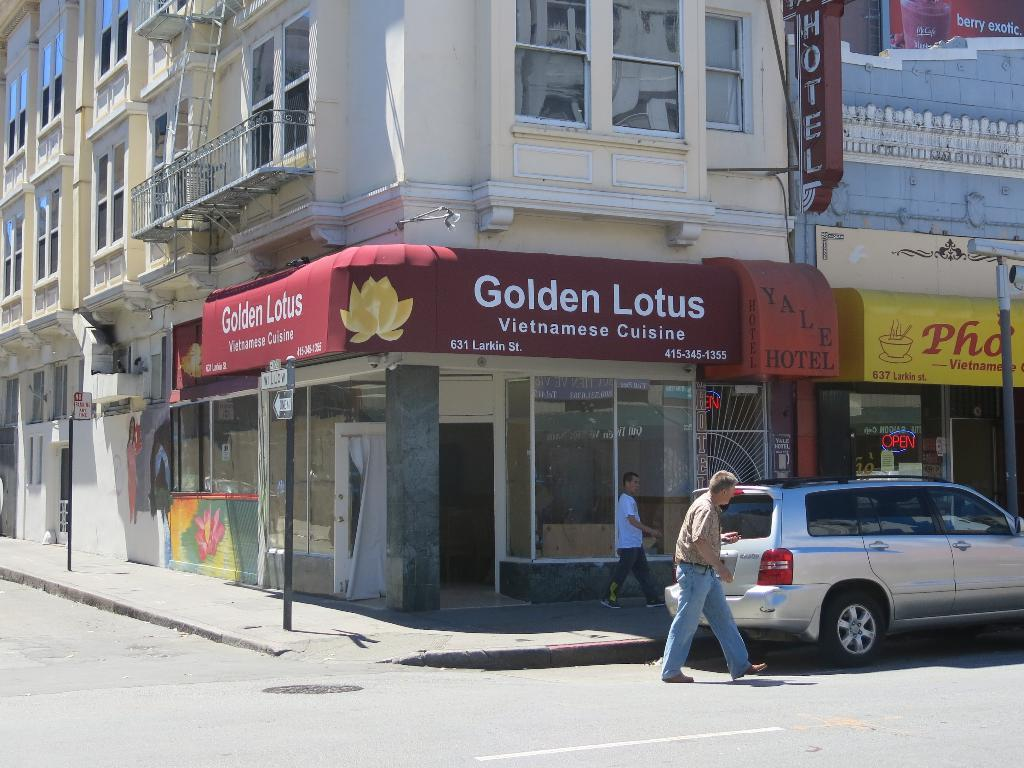How many people are walking in the image? There are two persons walking in the image. What is the background of the image? The persons are walking in front of a building. Where are the persons walking? The persons are on a road. What else can be seen on the right side of the image? There is a car on the right side of the image. What type of beds can be seen in the image? There are no beds present in the image. What kind of farm animals can be seen in the image? There are no farm animals present in the image. 